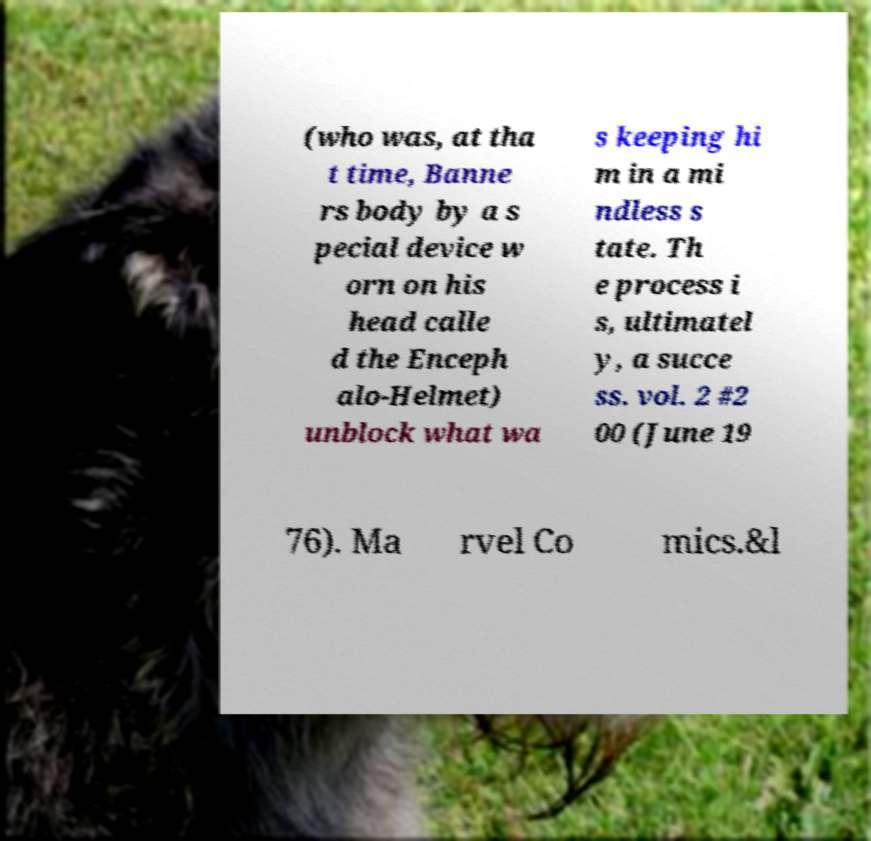Could you assist in decoding the text presented in this image and type it out clearly? (who was, at tha t time, Banne rs body by a s pecial device w orn on his head calle d the Enceph alo-Helmet) unblock what wa s keeping hi m in a mi ndless s tate. Th e process i s, ultimatel y, a succe ss. vol. 2 #2 00 (June 19 76). Ma rvel Co mics.&l 